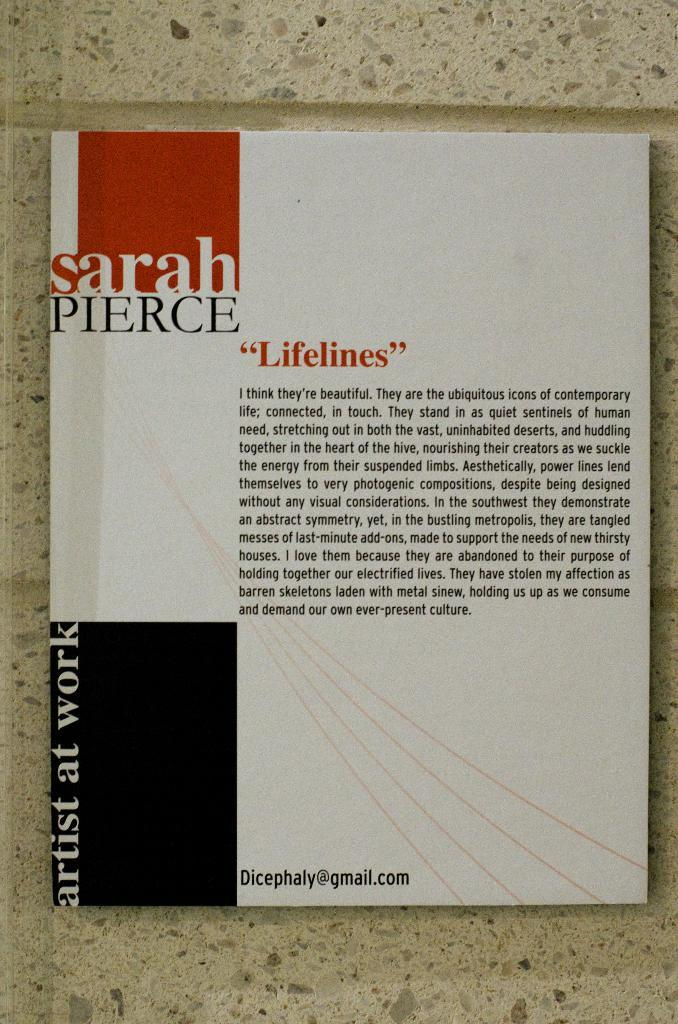<image>
Create a compact narrative representing the image presented. A paragraph titled Lifelines by Sarah Pierce in Artist At Work. 